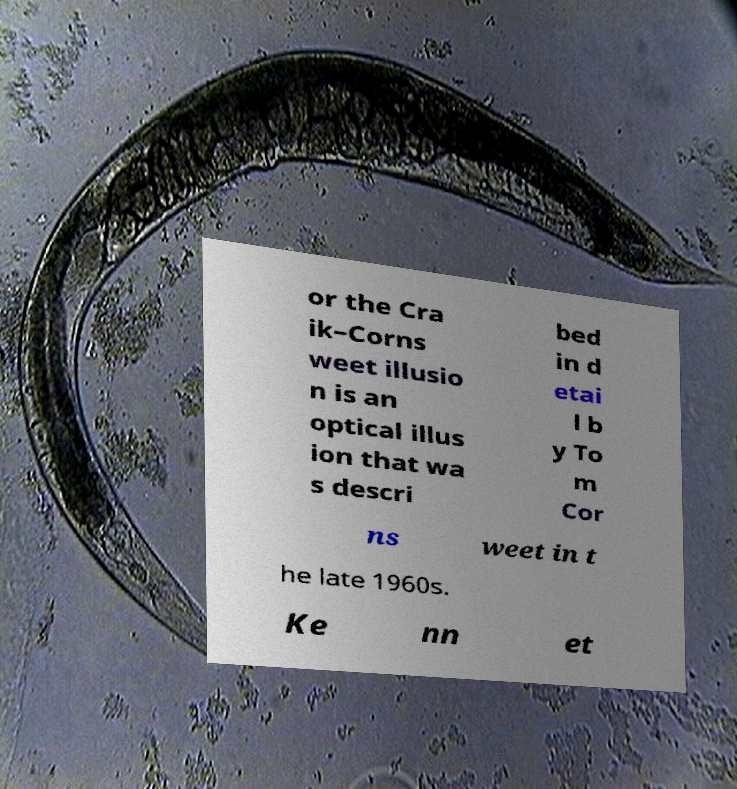Can you read and provide the text displayed in the image?This photo seems to have some interesting text. Can you extract and type it out for me? or the Cra ik–Corns weet illusio n is an optical illus ion that wa s descri bed in d etai l b y To m Cor ns weet in t he late 1960s. Ke nn et 